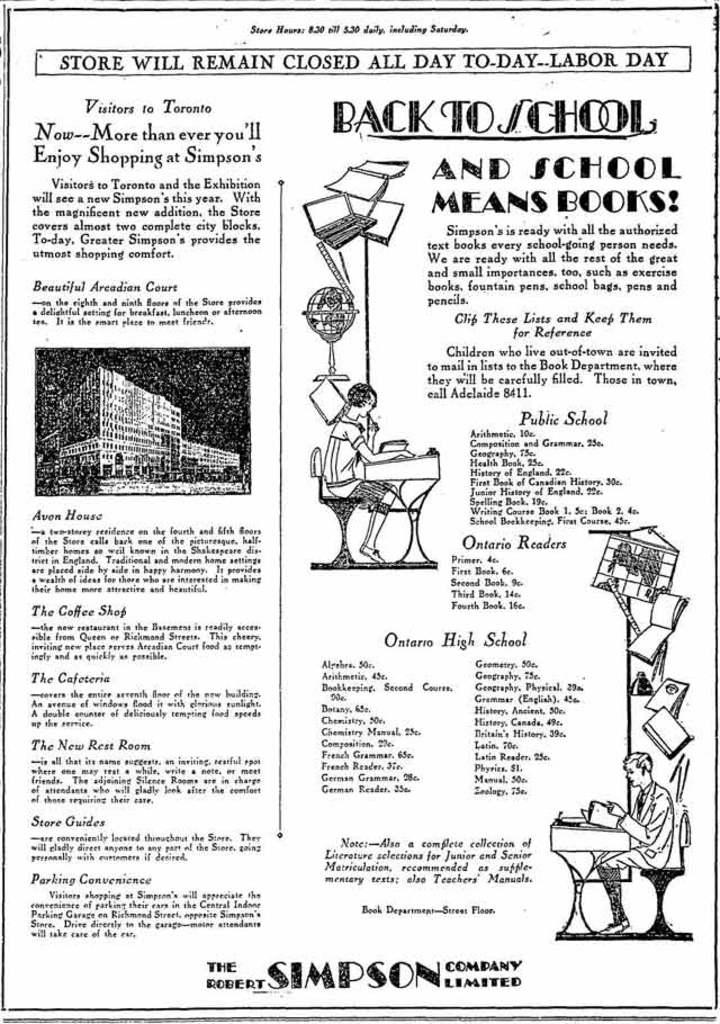What is present on the paper in the image? There is text and images of buildings, persons, and other things on the paper in the image. What is the paper placed on in the image? The paper is placed on a table in the image. What other items can be seen on the table? There are images of books on the table in the image. What type of paste is used to hold the nerve in the image? There is no mention of paste or nerves in the image; it only contains a paper with text and images. 